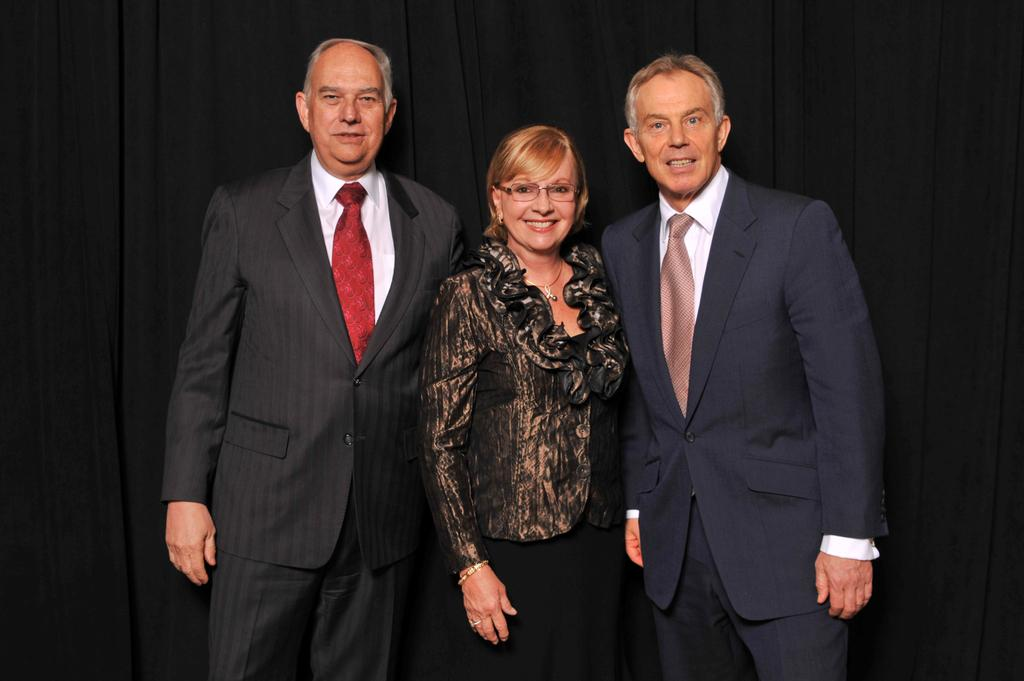What can be seen in the foreground of the image? There are persons standing in the front of the image. What is the facial expression of the persons in the image? The persons are smiling. What is present in the background of the image? There is a curtain in the background of the image. What is the color of the curtain? The curtain is black in color. Can you see any fog in the image? There is no fog present in the image. What is the bit that the persons are holding in the image? There is no bit present in the image; the persons are not holding anything. 